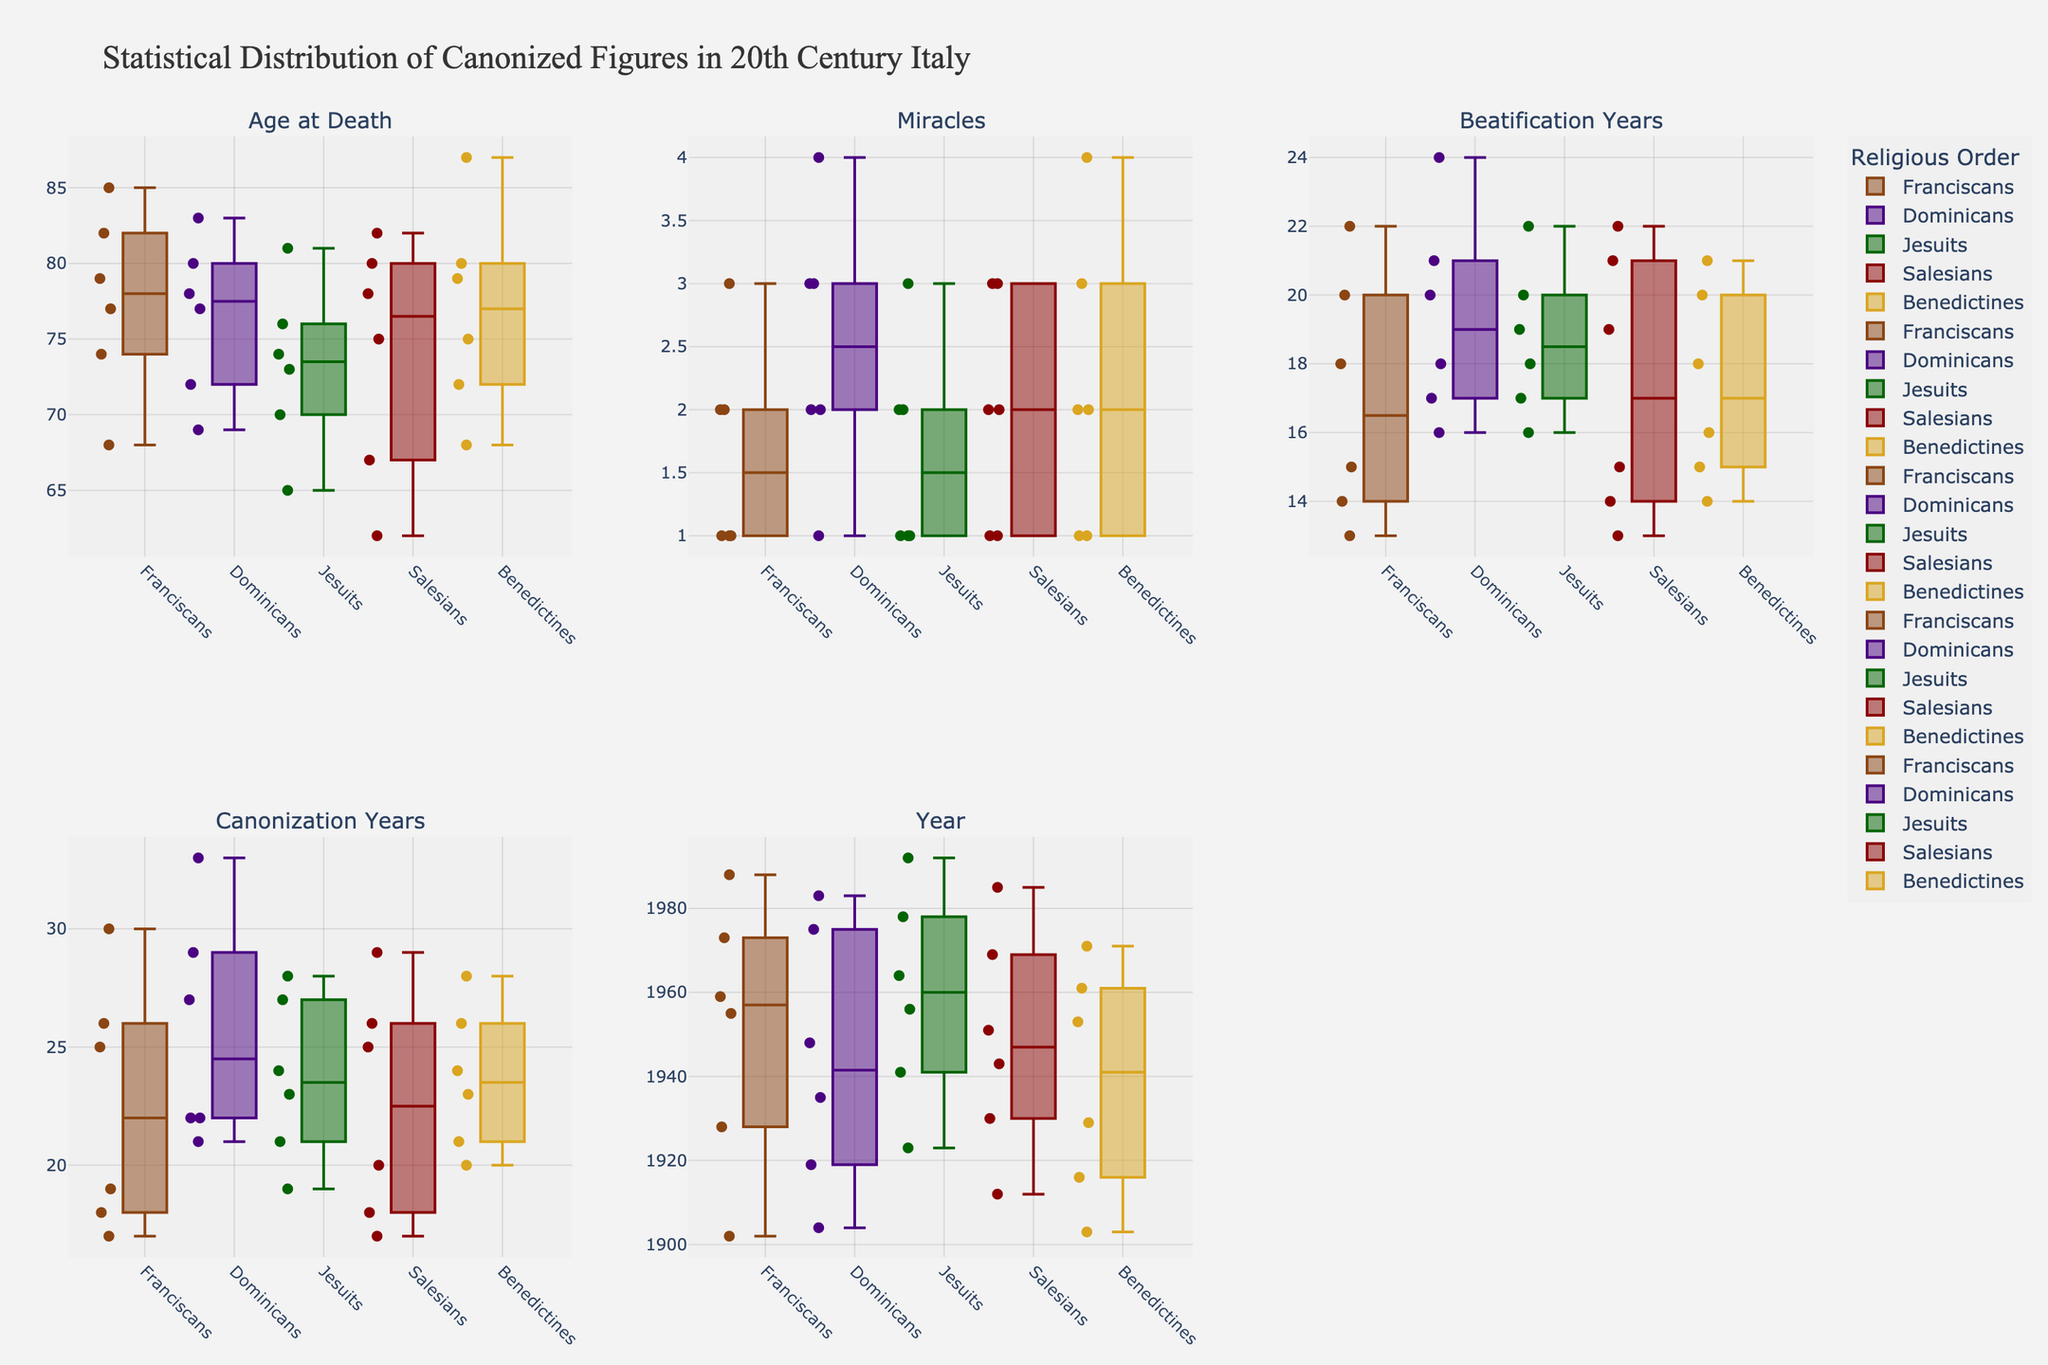What is the title of the figure? The title is found at the top center of the figure and usually summarizes the content presented in the plots.
Answer: Statistical Distribution of Canonized Figures in 20th Century Italy Which religious order shows the highest median age at death in the "Age at Death" subplot? To determine the highest median age, examine the middle line of each box plot in the "Age at Death" subplot. Identify which box plot has the highest middle line.
Answer: Benedictines How many religious orders had their beatification years represented in the "Beatification Years" subplot? Each order's box plot in the "Beatification Years" subplot represents their respective beatification years. Count the number of unique box plots.
Answer: Five Which religious order had the widest range for miracles in the "Miracles" subplot? The range of a box plot is the difference between its maximum and minimum values. Observe the length of the whiskers for each box plot in the "Miracles" subplot to determine which one is the widest.
Answer: Dominicans Which subplot contains data points for the year of canonization? Each subplot corresponds to a title that indicates its content. Look for the subplot with the title "Canonization Years."
Answer: Canonization Years Which religious order had the youngest median age at death based on the "Age at Death" subplot? Identify the box plot with the lowest middle line in the "Age at Death" subplot to find the order with the youngest median age.
Answer: Jesuits Compare the median number of miracles between Franciscans and Salesians. Which order had more? Check the "Miracles" subplot and compare the middle lines of the box plots for Franciscans and Salesians to determine which one is higher.
Answer: Dominicans What is the median beatification year for the Jesuits based on the "Beatification Years" subplot? Find the box plot for Jesuits in the "Beatification Years" subplot, then locate the middle line (median) of that box plot.
Answer: 18 Which religious order shows the smallest interquartile range (IQR) for canonization years in the "Canonization Years" subplot? The IQR is the length of the box in the box plot. Identify the box plot with the shortest box length in the "Canonization Years" subplot.
Answer: Franciscans Is there any order that showed a consistent number of canonization years (no outliers) in the "Canonization Years" subplot? If yes, which one? Check the "Canonization Years" subplot for any box plot without outliers (points outside the whiskers). Identify the order associated with this box plot.
Answer: Franciscans 